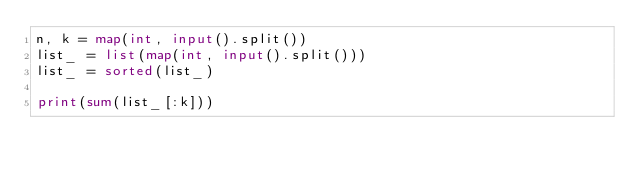<code> <loc_0><loc_0><loc_500><loc_500><_Python_>n, k = map(int, input().split())
list_ = list(map(int, input().split()))
list_ = sorted(list_)

print(sum(list_[:k]))</code> 